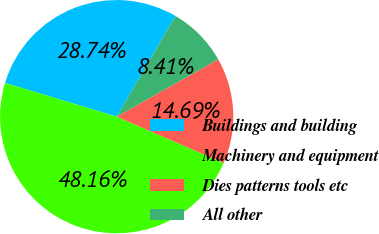Convert chart. <chart><loc_0><loc_0><loc_500><loc_500><pie_chart><fcel>Buildings and building<fcel>Machinery and equipment<fcel>Dies patterns tools etc<fcel>All other<nl><fcel>28.74%<fcel>48.16%<fcel>14.69%<fcel>8.41%<nl></chart> 